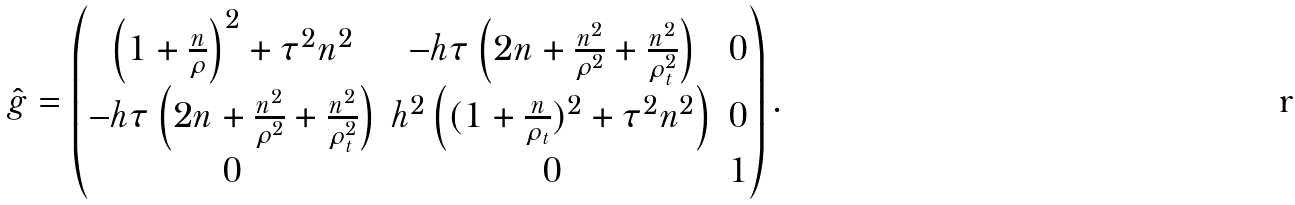<formula> <loc_0><loc_0><loc_500><loc_500>\hat { g } = \begin{pmatrix} \left ( 1 + \frac { n } { \rho } \right ) ^ { 2 } + \tau ^ { 2 } n ^ { 2 } & - h \tau \left ( 2 n + \frac { n ^ { 2 } } { \rho ^ { 2 } } + \frac { n ^ { 2 } } { \rho _ { t } ^ { 2 } } \right ) & 0 \\ - h \tau \left ( 2 n + \frac { n ^ { 2 } } { \rho ^ { 2 } } + \frac { n ^ { 2 } } { \rho _ { t } ^ { 2 } } \right ) & h ^ { 2 } \left ( ( 1 + \frac { n } { \rho _ { t } } ) ^ { 2 } + \tau ^ { 2 } n ^ { 2 } \right ) & 0 \\ 0 & 0 & 1 \\ \end{pmatrix} .</formula> 